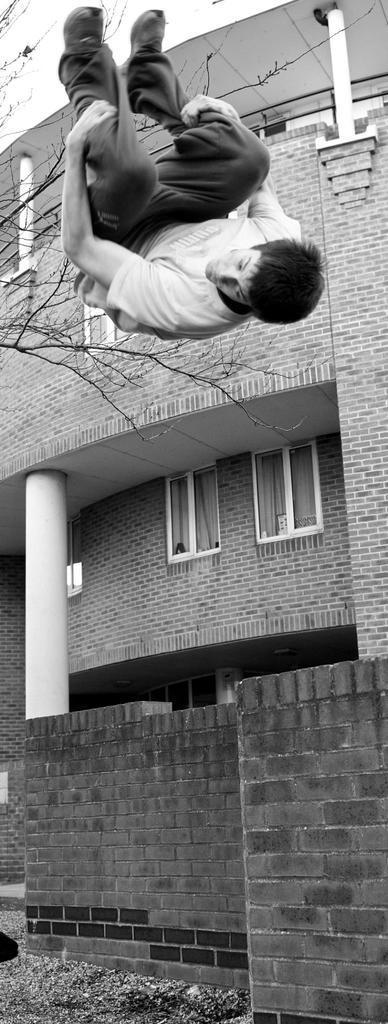Describe this image in one or two sentences. In the image we can see there is a man jumping in the air and there is a wall made up of bricks. Behind there is a building and there are windows on the building. The wall of the building is made up of bricks and the image is in black and white colour. 